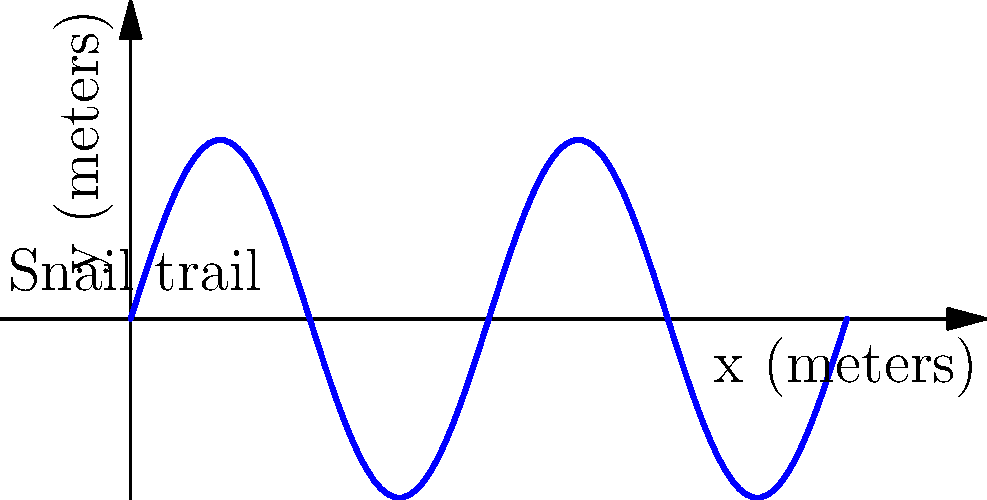As a snail enthusiast, you've observed a unique trail left by a garden snail. The trail can be represented by the sine function $y = 0.5 \sin(2\pi x)$ over the interval $[0, 2]$ meters. Calculate the approximate length of the snail's trail. Use the arc length formula and integrate numerically using Simpson's rule with 4 subintervals. To solve this problem, we'll follow these steps:

1) The arc length formula for a curve $y = f(x)$ from $a$ to $b$ is:

   $L = \int_{a}^{b} \sqrt{1 + [f'(x)]^2} dx$

2) In our case, $f(x) = 0.5 \sin(2\pi x)$, so $f'(x) = \pi \cos(2\pi x)$

3) Substituting into the arc length formula:

   $L = \int_{0}^{2} \sqrt{1 + [\pi \cos(2\pi x)]^2} dx$

4) We'll use Simpson's rule with 4 subintervals to approximate this integral. Simpson's rule is:

   $\int_{a}^{b} f(x) dx \approx \frac{h}{3}[f(x_0) + 4f(x_1) + 2f(x_2) + 4f(x_3) + f(x_4)]$

   where $h = \frac{b-a}{4}$ and $x_i = a + ih$

5) In our case:
   $h = \frac{2-0}{4} = 0.5$
   $x_0 = 0, x_1 = 0.5, x_2 = 1, x_3 = 1.5, x_4 = 2$

6) Let $g(x) = \sqrt{1 + [\pi \cos(2\pi x)]^2}$. We need to calculate:

   $g(0) = g(2) = \sqrt{1 + \pi^2} \approx 3.2899$
   $g(0.5) = g(1.5) = 1$
   $g(1) = \sqrt{1 + \pi^2} \approx 3.2899$

7) Applying Simpson's rule:

   $L \approx \frac{0.5}{3}[3.2899 + 4(1) + 2(3.2899) + 4(1) + 3.2899]$
      $= \frac{0.5}{3}[19.1596]$
      $\approx 3.1933$

Therefore, the approximate length of the snail's trail is 3.1933 meters.
Answer: $3.1933$ meters 